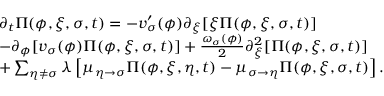Convert formula to latex. <formula><loc_0><loc_0><loc_500><loc_500>\begin{array} { r l } & { \partial _ { t } \Pi ( \phi , \xi , \sigma , t ) = - v _ { \sigma } ^ { \prime } ( \phi ) \partial _ { \xi } [ \xi \Pi ( \phi , \xi , \sigma , t ) ] } \\ & { - \partial _ { \phi } [ v _ { \sigma } ( \phi ) \Pi ( \phi , \xi , \sigma , t ) ] + \frac { \omega _ { \sigma } ( \phi ) } { 2 } \partial _ { \xi } ^ { 2 } [ \Pi ( \phi , \xi , \sigma , t ) ] } \\ & { + \sum _ { \eta \neq \sigma } \lambda \left [ \mu _ { \eta \rightarrow \sigma } \Pi ( \phi , \xi , \eta , t ) - \mu _ { \sigma \rightarrow \eta } \Pi ( \phi , \xi , \sigma , t ) \right ] . } \end{array}</formula> 